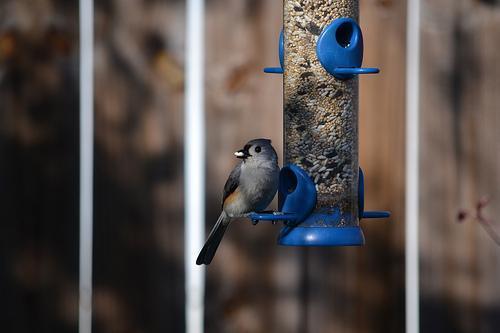How many perches are there?
Give a very brief answer. 4. How many birds are there?
Give a very brief answer. 1. How many feeders are there?
Give a very brief answer. 1. How many birds are flying around?
Give a very brief answer. 0. 